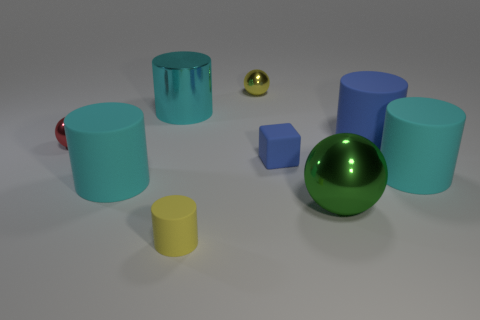Subtract all cyan cylinders. How many were subtracted if there are2cyan cylinders left? 1 Subtract all yellow blocks. How many cyan cylinders are left? 3 Subtract all blue cylinders. How many cylinders are left? 4 Subtract all yellow cylinders. How many cylinders are left? 4 Subtract all yellow cylinders. Subtract all brown cubes. How many cylinders are left? 4 Add 1 red spheres. How many objects exist? 10 Subtract all blocks. How many objects are left? 8 Add 5 matte cylinders. How many matte cylinders exist? 9 Subtract 1 green spheres. How many objects are left? 8 Subtract all tiny yellow metallic things. Subtract all big objects. How many objects are left? 3 